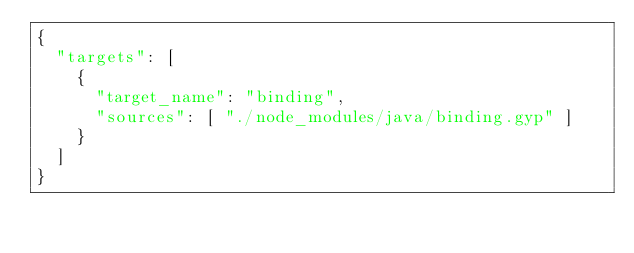Convert code to text. <code><loc_0><loc_0><loc_500><loc_500><_Python_>{
  "targets": [
    {
      "target_name": "binding",
      "sources": [ "./node_modules/java/binding.gyp" ]
    }
  ]
}
</code> 